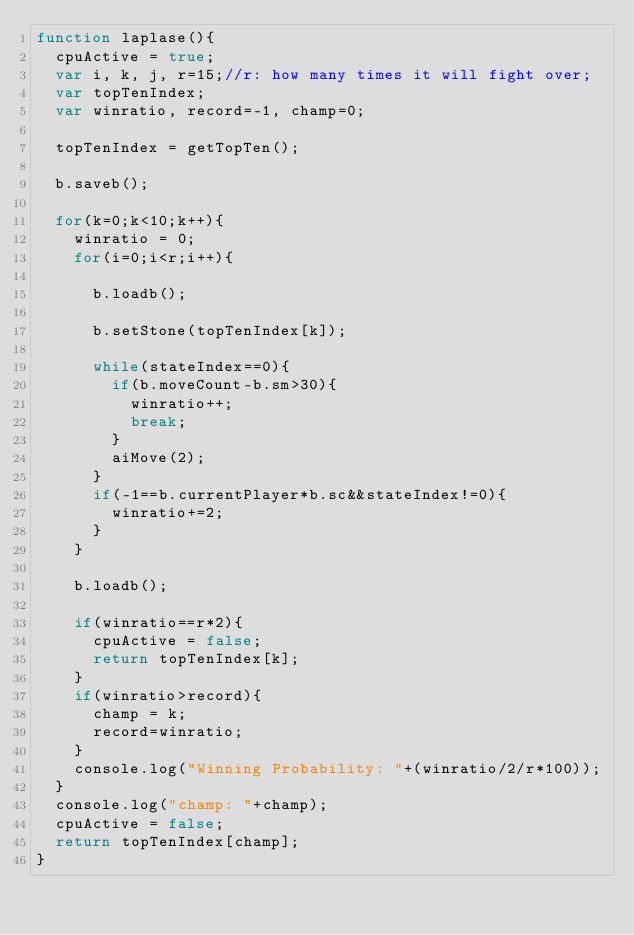<code> <loc_0><loc_0><loc_500><loc_500><_JavaScript_>function laplase(){
	cpuActive = true;
	var i, k, j, r=15;//r: how many times it will fight over;
	var topTenIndex;
	var winratio, record=-1, champ=0;

	topTenIndex = getTopTen();

	b.saveb();
	
	for(k=0;k<10;k++){
		winratio = 0;
		for(i=0;i<r;i++){
			
			b.loadb();
			
			b.setStone(topTenIndex[k]);

			while(stateIndex==0){
				if(b.moveCount-b.sm>30){
					winratio++;
					break;
				}
				aiMove(2);
			}
			if(-1==b.currentPlayer*b.sc&&stateIndex!=0){
				winratio+=2;
			}
		}

		b.loadb();
		
		if(winratio==r*2){
			cpuActive = false;
			return topTenIndex[k];
		}
		if(winratio>record){
			champ = k;
			record=winratio;
		}
		console.log("Winning Probability: "+(winratio/2/r*100));
	}
	console.log("champ: "+champ);
	cpuActive = false;
	return topTenIndex[champ];
}</code> 